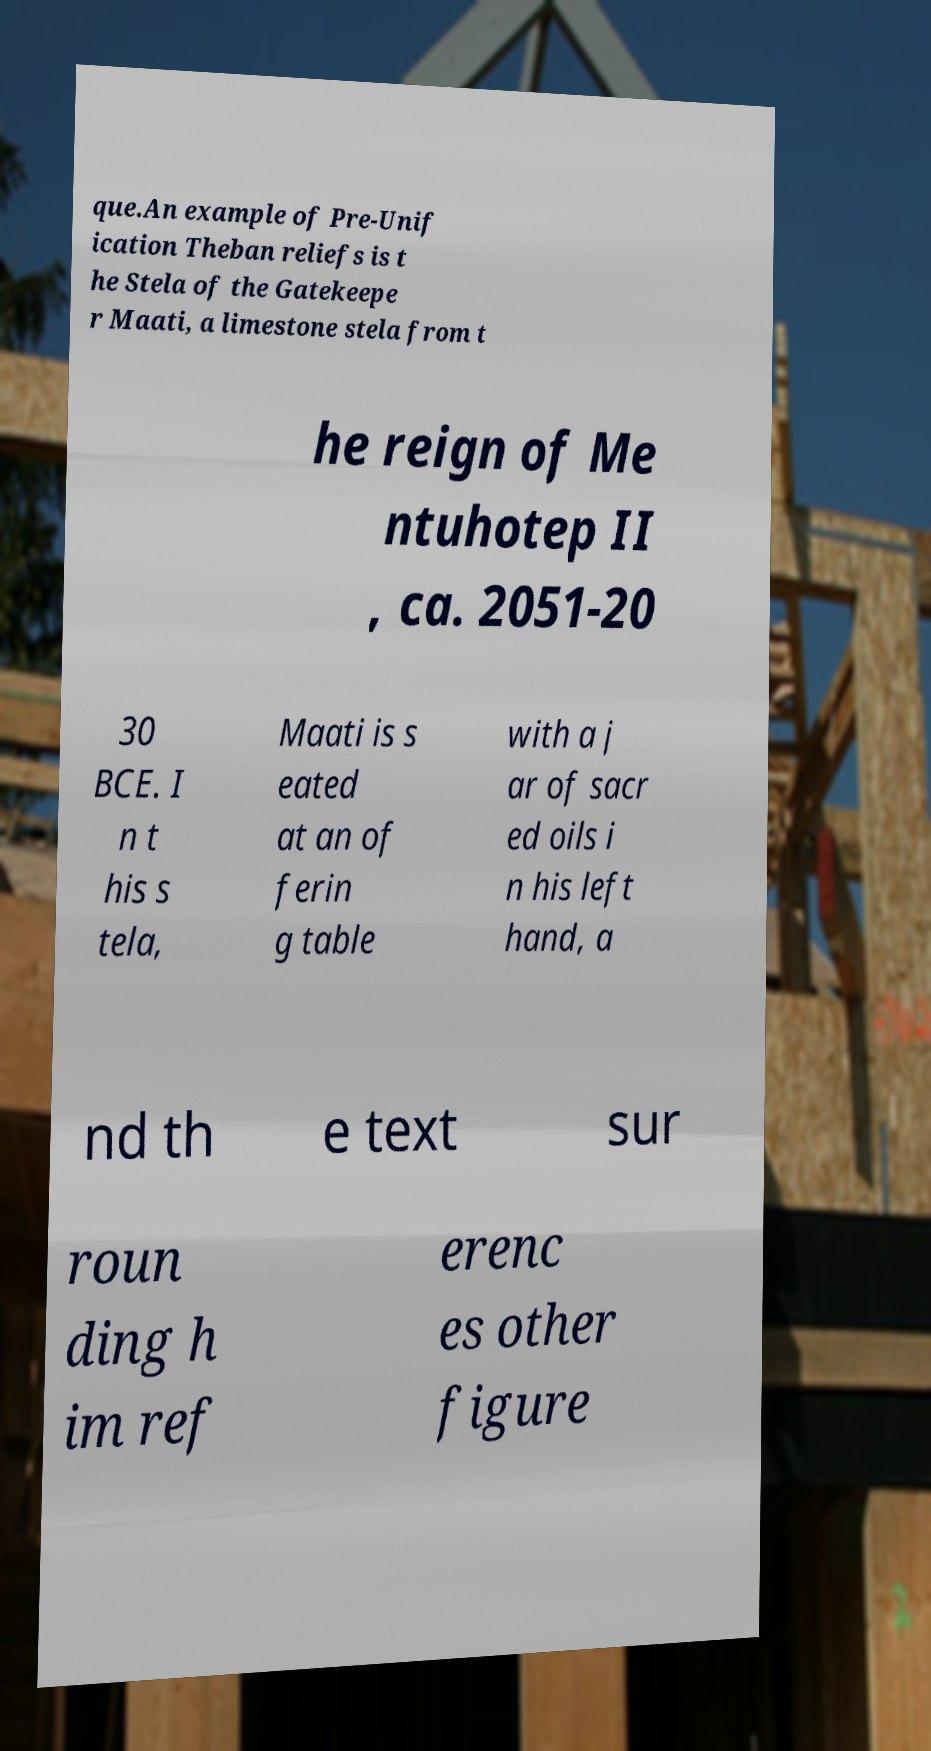Could you extract and type out the text from this image? que.An example of Pre-Unif ication Theban reliefs is t he Stela of the Gatekeepe r Maati, a limestone stela from t he reign of Me ntuhotep II , ca. 2051-20 30 BCE. I n t his s tela, Maati is s eated at an of ferin g table with a j ar of sacr ed oils i n his left hand, a nd th e text sur roun ding h im ref erenc es other figure 